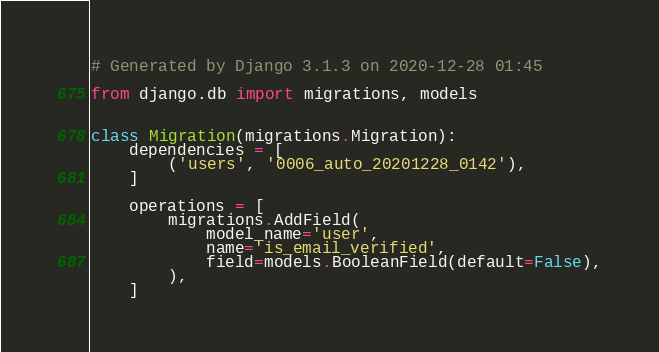<code> <loc_0><loc_0><loc_500><loc_500><_Python_># Generated by Django 3.1.3 on 2020-12-28 01:45

from django.db import migrations, models


class Migration(migrations.Migration):
    dependencies = [
        ('users', '0006_auto_20201228_0142'),
    ]

    operations = [
        migrations.AddField(
            model_name='user',
            name='is_email_verified',
            field=models.BooleanField(default=False),
        ),
    ]
</code> 